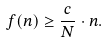Convert formula to latex. <formula><loc_0><loc_0><loc_500><loc_500>f ( n ) \geq \frac { c } { N } \cdot n .</formula> 